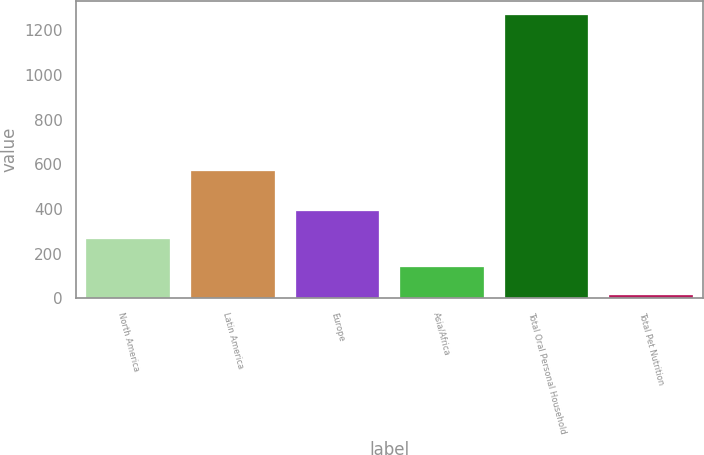Convert chart to OTSL. <chart><loc_0><loc_0><loc_500><loc_500><bar_chart><fcel>North America<fcel>Latin America<fcel>Europe<fcel>Asia/Africa<fcel>Total Oral Personal Household<fcel>Total Pet Nutrition<nl><fcel>265.84<fcel>568.7<fcel>391.26<fcel>140.42<fcel>1269.2<fcel>15<nl></chart> 